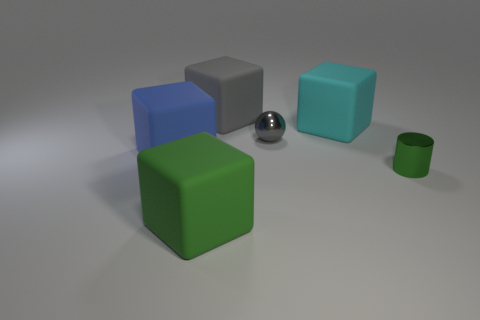Add 1 large purple rubber cubes. How many objects exist? 7 Subtract all balls. How many objects are left? 5 Add 5 spheres. How many spheres exist? 6 Subtract 0 yellow blocks. How many objects are left? 6 Subtract all tiny green cylinders. Subtract all green blocks. How many objects are left? 4 Add 3 large blocks. How many large blocks are left? 7 